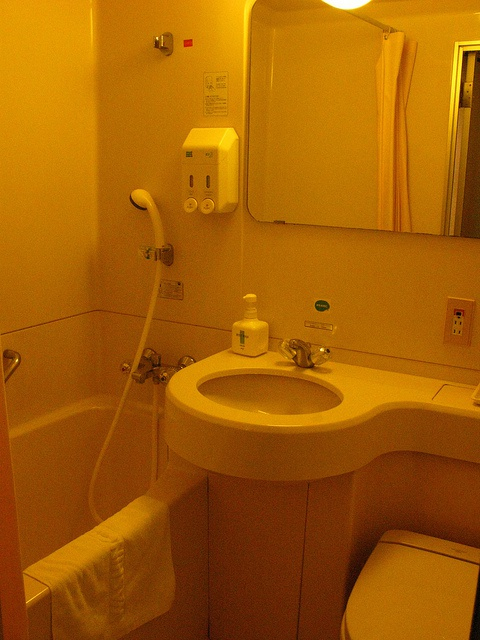Describe the objects in this image and their specific colors. I can see toilet in orange, maroon, and black tones, sink in orange, brown, and maroon tones, and bottle in orange and olive tones in this image. 